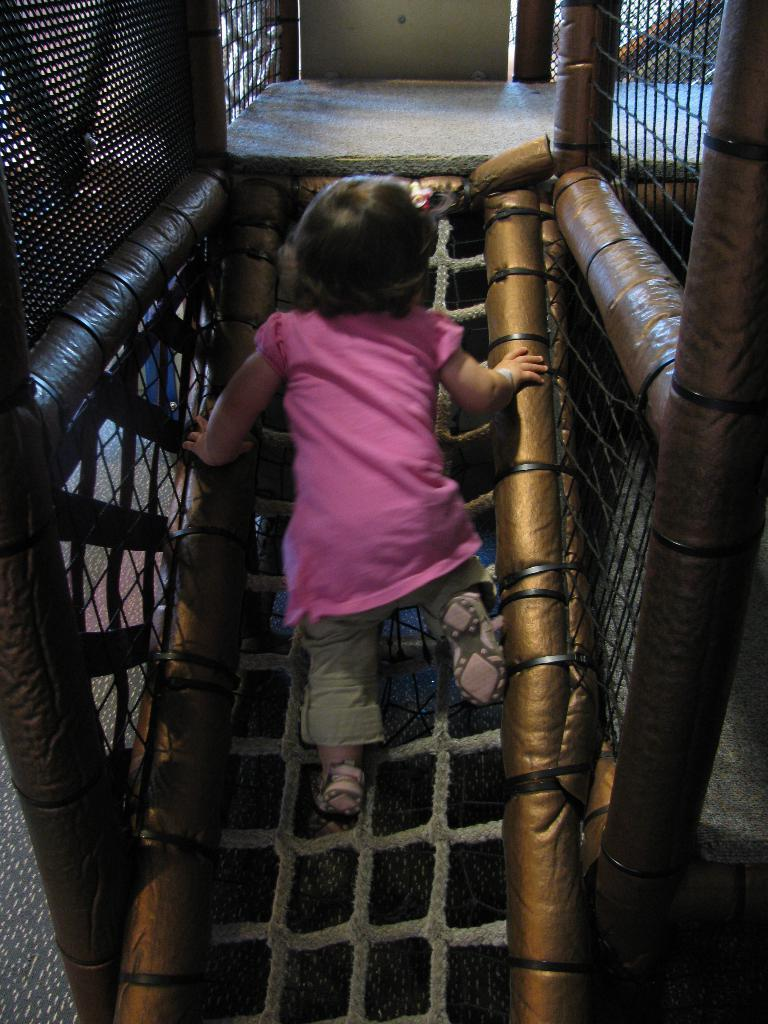What is the main subject of the image? The main subject of the image is a small child. What is the child doing in the image? The child is walking on a rope ladder. What type of arch can be seen in the background of the image? There is no arch present in the image; it only features a small child walking on a rope ladder. 